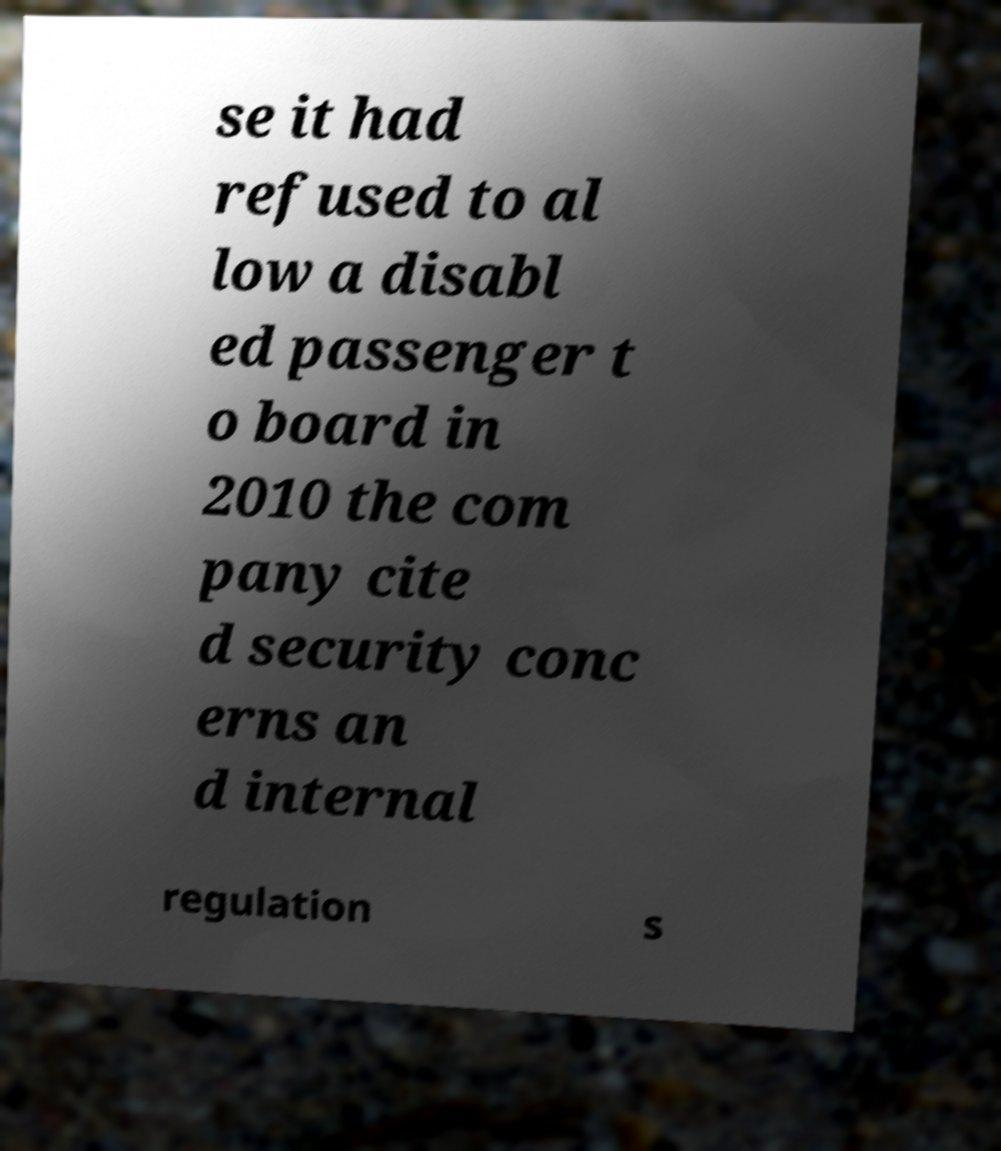Could you extract and type out the text from this image? se it had refused to al low a disabl ed passenger t o board in 2010 the com pany cite d security conc erns an d internal regulation s 